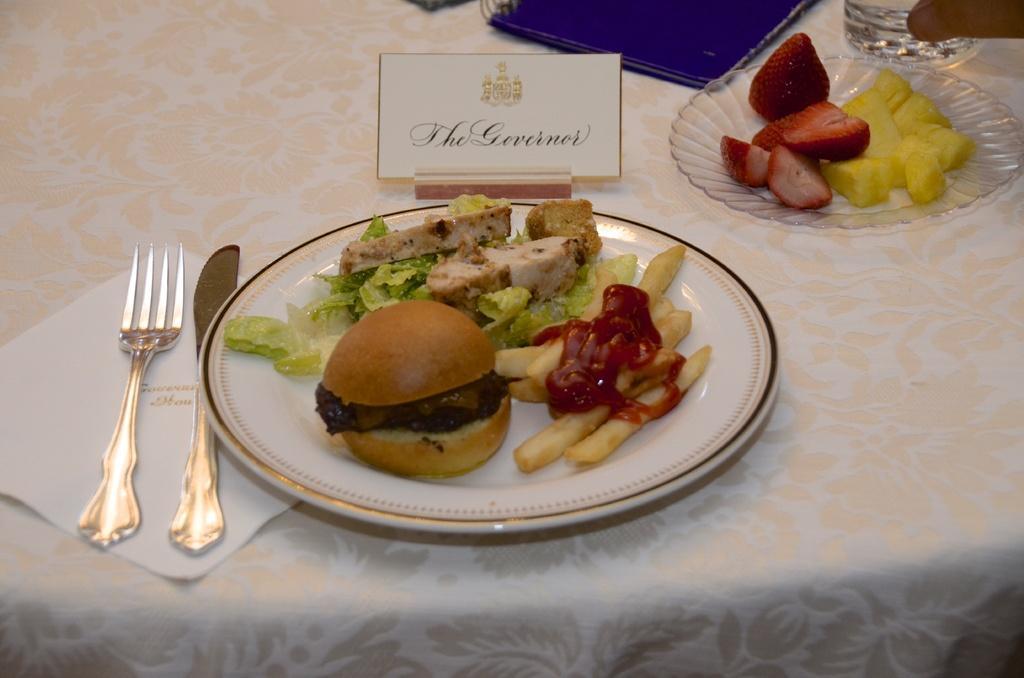Please provide a concise description of this image. In this image, we can see a table, on that table, we can see two plates, there is some food on the plates, we can see a fork and a tissue on the table, there is a small name board on the table. 